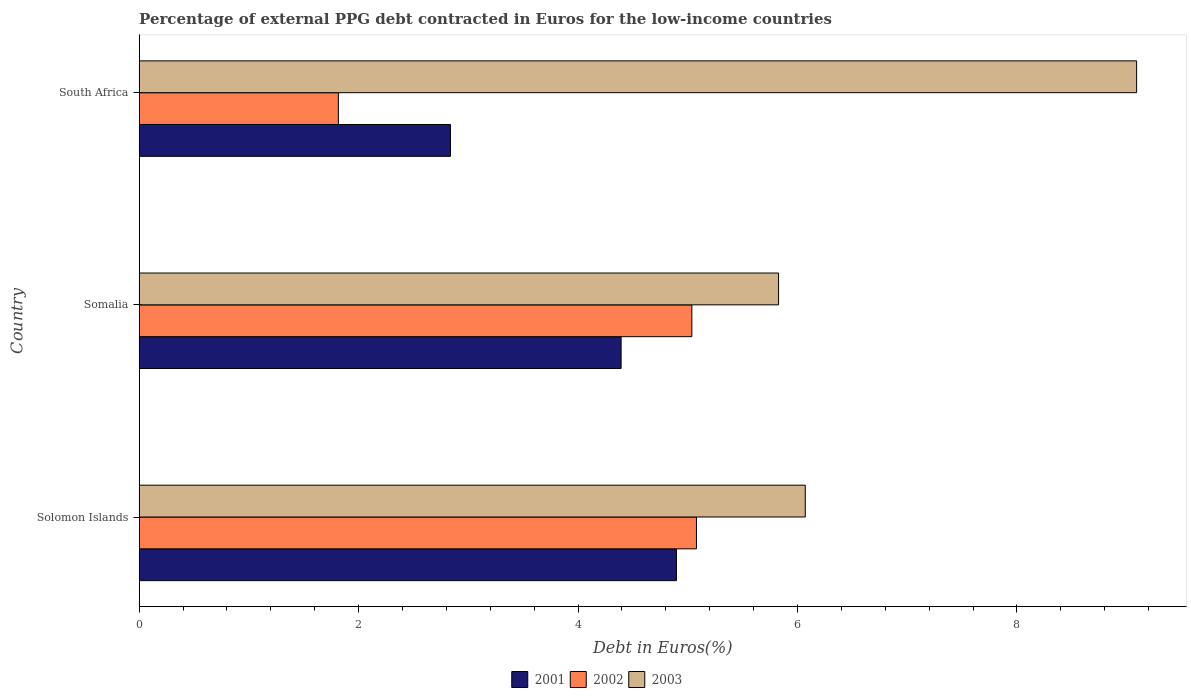Are the number of bars on each tick of the Y-axis equal?
Provide a short and direct response. Yes. How many bars are there on the 2nd tick from the top?
Keep it short and to the point. 3. How many bars are there on the 2nd tick from the bottom?
Make the answer very short. 3. What is the label of the 2nd group of bars from the top?
Keep it short and to the point. Somalia. What is the percentage of external PPG debt contracted in Euros in 2003 in Somalia?
Your answer should be compact. 5.83. Across all countries, what is the maximum percentage of external PPG debt contracted in Euros in 2002?
Ensure brevity in your answer.  5.08. Across all countries, what is the minimum percentage of external PPG debt contracted in Euros in 2002?
Make the answer very short. 1.82. In which country was the percentage of external PPG debt contracted in Euros in 2003 maximum?
Ensure brevity in your answer.  South Africa. In which country was the percentage of external PPG debt contracted in Euros in 2003 minimum?
Provide a short and direct response. Somalia. What is the total percentage of external PPG debt contracted in Euros in 2002 in the graph?
Give a very brief answer. 11.93. What is the difference between the percentage of external PPG debt contracted in Euros in 2003 in Solomon Islands and that in South Africa?
Your response must be concise. -3.02. What is the difference between the percentage of external PPG debt contracted in Euros in 2002 in Solomon Islands and the percentage of external PPG debt contracted in Euros in 2001 in South Africa?
Ensure brevity in your answer.  2.24. What is the average percentage of external PPG debt contracted in Euros in 2001 per country?
Make the answer very short. 4.04. What is the difference between the percentage of external PPG debt contracted in Euros in 2002 and percentage of external PPG debt contracted in Euros in 2003 in South Africa?
Your answer should be very brief. -7.28. What is the ratio of the percentage of external PPG debt contracted in Euros in 2003 in Somalia to that in South Africa?
Keep it short and to the point. 0.64. What is the difference between the highest and the second highest percentage of external PPG debt contracted in Euros in 2001?
Your answer should be compact. 0.5. What is the difference between the highest and the lowest percentage of external PPG debt contracted in Euros in 2002?
Give a very brief answer. 3.26. In how many countries, is the percentage of external PPG debt contracted in Euros in 2003 greater than the average percentage of external PPG debt contracted in Euros in 2003 taken over all countries?
Give a very brief answer. 1. Is the sum of the percentage of external PPG debt contracted in Euros in 2001 in Solomon Islands and South Africa greater than the maximum percentage of external PPG debt contracted in Euros in 2002 across all countries?
Make the answer very short. Yes. What does the 1st bar from the bottom in South Africa represents?
Give a very brief answer. 2001. Is it the case that in every country, the sum of the percentage of external PPG debt contracted in Euros in 2001 and percentage of external PPG debt contracted in Euros in 2003 is greater than the percentage of external PPG debt contracted in Euros in 2002?
Your answer should be compact. Yes. Are all the bars in the graph horizontal?
Your answer should be very brief. Yes. How many countries are there in the graph?
Provide a short and direct response. 3. What is the difference between two consecutive major ticks on the X-axis?
Keep it short and to the point. 2. Are the values on the major ticks of X-axis written in scientific E-notation?
Make the answer very short. No. Does the graph contain any zero values?
Your answer should be compact. No. What is the title of the graph?
Offer a terse response. Percentage of external PPG debt contracted in Euros for the low-income countries. Does "1974" appear as one of the legend labels in the graph?
Provide a succinct answer. No. What is the label or title of the X-axis?
Keep it short and to the point. Debt in Euros(%). What is the Debt in Euros(%) of 2001 in Solomon Islands?
Offer a very short reply. 4.9. What is the Debt in Euros(%) of 2002 in Solomon Islands?
Make the answer very short. 5.08. What is the Debt in Euros(%) of 2003 in Solomon Islands?
Provide a short and direct response. 6.07. What is the Debt in Euros(%) of 2001 in Somalia?
Provide a succinct answer. 4.39. What is the Debt in Euros(%) of 2002 in Somalia?
Give a very brief answer. 5.04. What is the Debt in Euros(%) of 2003 in Somalia?
Provide a short and direct response. 5.83. What is the Debt in Euros(%) of 2001 in South Africa?
Keep it short and to the point. 2.84. What is the Debt in Euros(%) in 2002 in South Africa?
Your answer should be compact. 1.82. What is the Debt in Euros(%) in 2003 in South Africa?
Your answer should be very brief. 9.09. Across all countries, what is the maximum Debt in Euros(%) of 2001?
Offer a very short reply. 4.9. Across all countries, what is the maximum Debt in Euros(%) in 2002?
Make the answer very short. 5.08. Across all countries, what is the maximum Debt in Euros(%) in 2003?
Ensure brevity in your answer.  9.09. Across all countries, what is the minimum Debt in Euros(%) in 2001?
Provide a short and direct response. 2.84. Across all countries, what is the minimum Debt in Euros(%) in 2002?
Provide a short and direct response. 1.82. Across all countries, what is the minimum Debt in Euros(%) in 2003?
Your response must be concise. 5.83. What is the total Debt in Euros(%) of 2001 in the graph?
Offer a terse response. 12.13. What is the total Debt in Euros(%) in 2002 in the graph?
Give a very brief answer. 11.93. What is the total Debt in Euros(%) of 2003 in the graph?
Your response must be concise. 20.99. What is the difference between the Debt in Euros(%) of 2001 in Solomon Islands and that in Somalia?
Provide a short and direct response. 0.5. What is the difference between the Debt in Euros(%) of 2002 in Solomon Islands and that in Somalia?
Keep it short and to the point. 0.04. What is the difference between the Debt in Euros(%) of 2003 in Solomon Islands and that in Somalia?
Your answer should be very brief. 0.24. What is the difference between the Debt in Euros(%) of 2001 in Solomon Islands and that in South Africa?
Give a very brief answer. 2.06. What is the difference between the Debt in Euros(%) of 2002 in Solomon Islands and that in South Africa?
Ensure brevity in your answer.  3.26. What is the difference between the Debt in Euros(%) of 2003 in Solomon Islands and that in South Africa?
Make the answer very short. -3.02. What is the difference between the Debt in Euros(%) in 2001 in Somalia and that in South Africa?
Offer a very short reply. 1.56. What is the difference between the Debt in Euros(%) of 2002 in Somalia and that in South Africa?
Your response must be concise. 3.22. What is the difference between the Debt in Euros(%) of 2003 in Somalia and that in South Africa?
Ensure brevity in your answer.  -3.26. What is the difference between the Debt in Euros(%) of 2001 in Solomon Islands and the Debt in Euros(%) of 2002 in Somalia?
Offer a very short reply. -0.14. What is the difference between the Debt in Euros(%) in 2001 in Solomon Islands and the Debt in Euros(%) in 2003 in Somalia?
Provide a short and direct response. -0.93. What is the difference between the Debt in Euros(%) in 2002 in Solomon Islands and the Debt in Euros(%) in 2003 in Somalia?
Ensure brevity in your answer.  -0.75. What is the difference between the Debt in Euros(%) of 2001 in Solomon Islands and the Debt in Euros(%) of 2002 in South Africa?
Provide a succinct answer. 3.08. What is the difference between the Debt in Euros(%) of 2001 in Solomon Islands and the Debt in Euros(%) of 2003 in South Africa?
Your answer should be compact. -4.19. What is the difference between the Debt in Euros(%) in 2002 in Solomon Islands and the Debt in Euros(%) in 2003 in South Africa?
Offer a very short reply. -4.01. What is the difference between the Debt in Euros(%) of 2001 in Somalia and the Debt in Euros(%) of 2002 in South Africa?
Provide a short and direct response. 2.58. What is the difference between the Debt in Euros(%) in 2001 in Somalia and the Debt in Euros(%) in 2003 in South Africa?
Your answer should be very brief. -4.7. What is the difference between the Debt in Euros(%) of 2002 in Somalia and the Debt in Euros(%) of 2003 in South Africa?
Give a very brief answer. -4.05. What is the average Debt in Euros(%) of 2001 per country?
Provide a succinct answer. 4.04. What is the average Debt in Euros(%) of 2002 per country?
Offer a very short reply. 3.98. What is the average Debt in Euros(%) in 2003 per country?
Provide a short and direct response. 7. What is the difference between the Debt in Euros(%) of 2001 and Debt in Euros(%) of 2002 in Solomon Islands?
Provide a short and direct response. -0.18. What is the difference between the Debt in Euros(%) of 2001 and Debt in Euros(%) of 2003 in Solomon Islands?
Your answer should be very brief. -1.17. What is the difference between the Debt in Euros(%) of 2002 and Debt in Euros(%) of 2003 in Solomon Islands?
Provide a succinct answer. -0.99. What is the difference between the Debt in Euros(%) in 2001 and Debt in Euros(%) in 2002 in Somalia?
Your answer should be compact. -0.64. What is the difference between the Debt in Euros(%) in 2001 and Debt in Euros(%) in 2003 in Somalia?
Your answer should be compact. -1.43. What is the difference between the Debt in Euros(%) in 2002 and Debt in Euros(%) in 2003 in Somalia?
Your answer should be very brief. -0.79. What is the difference between the Debt in Euros(%) of 2001 and Debt in Euros(%) of 2002 in South Africa?
Your response must be concise. 1.02. What is the difference between the Debt in Euros(%) in 2001 and Debt in Euros(%) in 2003 in South Africa?
Provide a short and direct response. -6.25. What is the difference between the Debt in Euros(%) in 2002 and Debt in Euros(%) in 2003 in South Africa?
Make the answer very short. -7.28. What is the ratio of the Debt in Euros(%) of 2001 in Solomon Islands to that in Somalia?
Ensure brevity in your answer.  1.11. What is the ratio of the Debt in Euros(%) of 2002 in Solomon Islands to that in Somalia?
Provide a succinct answer. 1.01. What is the ratio of the Debt in Euros(%) of 2003 in Solomon Islands to that in Somalia?
Make the answer very short. 1.04. What is the ratio of the Debt in Euros(%) of 2001 in Solomon Islands to that in South Africa?
Ensure brevity in your answer.  1.73. What is the ratio of the Debt in Euros(%) in 2002 in Solomon Islands to that in South Africa?
Give a very brief answer. 2.8. What is the ratio of the Debt in Euros(%) of 2003 in Solomon Islands to that in South Africa?
Offer a very short reply. 0.67. What is the ratio of the Debt in Euros(%) of 2001 in Somalia to that in South Africa?
Your response must be concise. 1.55. What is the ratio of the Debt in Euros(%) in 2002 in Somalia to that in South Africa?
Keep it short and to the point. 2.77. What is the ratio of the Debt in Euros(%) in 2003 in Somalia to that in South Africa?
Provide a succinct answer. 0.64. What is the difference between the highest and the second highest Debt in Euros(%) in 2001?
Provide a short and direct response. 0.5. What is the difference between the highest and the second highest Debt in Euros(%) in 2002?
Provide a succinct answer. 0.04. What is the difference between the highest and the second highest Debt in Euros(%) of 2003?
Your answer should be compact. 3.02. What is the difference between the highest and the lowest Debt in Euros(%) of 2001?
Your answer should be compact. 2.06. What is the difference between the highest and the lowest Debt in Euros(%) in 2002?
Provide a succinct answer. 3.26. What is the difference between the highest and the lowest Debt in Euros(%) in 2003?
Offer a terse response. 3.26. 